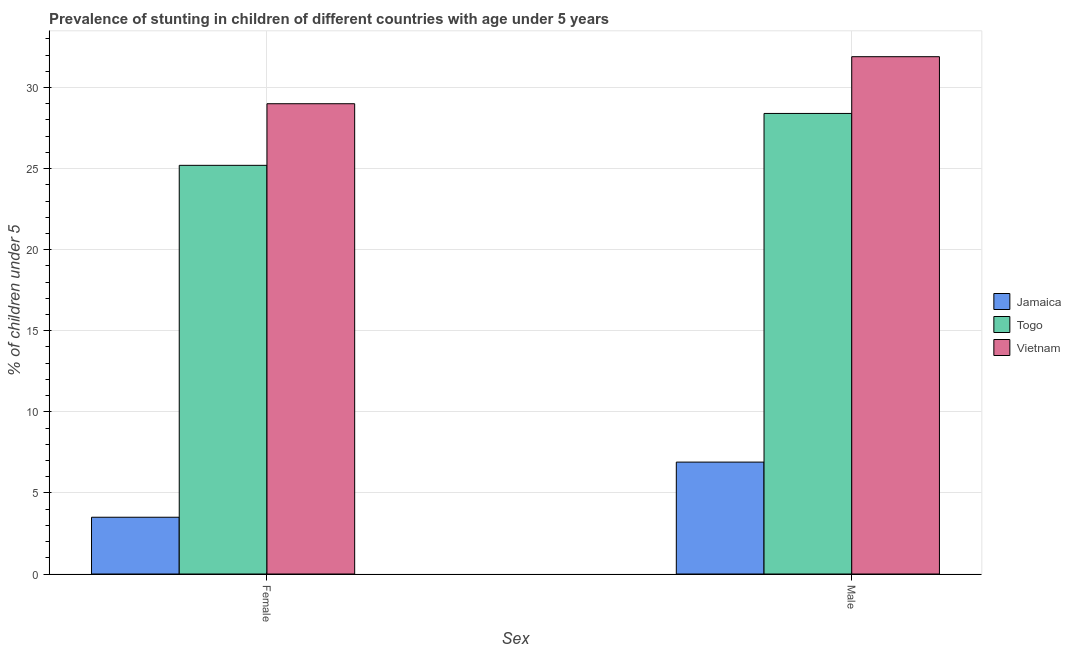Are the number of bars per tick equal to the number of legend labels?
Provide a short and direct response. Yes. How many bars are there on the 1st tick from the left?
Offer a very short reply. 3. How many bars are there on the 2nd tick from the right?
Your answer should be very brief. 3. What is the label of the 1st group of bars from the left?
Your response must be concise. Female. What is the percentage of stunted female children in Togo?
Your answer should be very brief. 25.2. Across all countries, what is the maximum percentage of stunted male children?
Make the answer very short. 31.9. Across all countries, what is the minimum percentage of stunted female children?
Your answer should be very brief. 3.5. In which country was the percentage of stunted male children maximum?
Provide a short and direct response. Vietnam. In which country was the percentage of stunted female children minimum?
Your answer should be compact. Jamaica. What is the total percentage of stunted female children in the graph?
Provide a succinct answer. 57.7. What is the difference between the percentage of stunted male children in Jamaica and that in Vietnam?
Offer a terse response. -25. What is the difference between the percentage of stunted female children in Vietnam and the percentage of stunted male children in Jamaica?
Your answer should be very brief. 22.1. What is the average percentage of stunted male children per country?
Your response must be concise. 22.4. What is the difference between the percentage of stunted female children and percentage of stunted male children in Vietnam?
Keep it short and to the point. -2.9. In how many countries, is the percentage of stunted female children greater than 8 %?
Provide a short and direct response. 2. What is the ratio of the percentage of stunted male children in Vietnam to that in Togo?
Ensure brevity in your answer.  1.12. What does the 3rd bar from the left in Male represents?
Make the answer very short. Vietnam. What does the 2nd bar from the right in Female represents?
Offer a terse response. Togo. Are all the bars in the graph horizontal?
Offer a terse response. No. Where does the legend appear in the graph?
Your answer should be very brief. Center right. What is the title of the graph?
Give a very brief answer. Prevalence of stunting in children of different countries with age under 5 years. Does "Tuvalu" appear as one of the legend labels in the graph?
Your answer should be very brief. No. What is the label or title of the X-axis?
Give a very brief answer. Sex. What is the label or title of the Y-axis?
Make the answer very short.  % of children under 5. What is the  % of children under 5 in Jamaica in Female?
Ensure brevity in your answer.  3.5. What is the  % of children under 5 in Togo in Female?
Your answer should be very brief. 25.2. What is the  % of children under 5 of Vietnam in Female?
Keep it short and to the point. 29. What is the  % of children under 5 of Jamaica in Male?
Provide a succinct answer. 6.9. What is the  % of children under 5 in Togo in Male?
Provide a short and direct response. 28.4. What is the  % of children under 5 of Vietnam in Male?
Your answer should be very brief. 31.9. Across all Sex, what is the maximum  % of children under 5 of Jamaica?
Provide a short and direct response. 6.9. Across all Sex, what is the maximum  % of children under 5 of Togo?
Your answer should be compact. 28.4. Across all Sex, what is the maximum  % of children under 5 in Vietnam?
Offer a terse response. 31.9. Across all Sex, what is the minimum  % of children under 5 of Jamaica?
Ensure brevity in your answer.  3.5. Across all Sex, what is the minimum  % of children under 5 in Togo?
Offer a very short reply. 25.2. Across all Sex, what is the minimum  % of children under 5 in Vietnam?
Your answer should be compact. 29. What is the total  % of children under 5 in Togo in the graph?
Provide a succinct answer. 53.6. What is the total  % of children under 5 in Vietnam in the graph?
Provide a succinct answer. 60.9. What is the difference between the  % of children under 5 in Jamaica in Female and that in Male?
Your answer should be compact. -3.4. What is the difference between the  % of children under 5 in Togo in Female and that in Male?
Keep it short and to the point. -3.2. What is the difference between the  % of children under 5 in Jamaica in Female and the  % of children under 5 in Togo in Male?
Offer a terse response. -24.9. What is the difference between the  % of children under 5 in Jamaica in Female and the  % of children under 5 in Vietnam in Male?
Keep it short and to the point. -28.4. What is the average  % of children under 5 in Togo per Sex?
Provide a short and direct response. 26.8. What is the average  % of children under 5 in Vietnam per Sex?
Keep it short and to the point. 30.45. What is the difference between the  % of children under 5 of Jamaica and  % of children under 5 of Togo in Female?
Provide a short and direct response. -21.7. What is the difference between the  % of children under 5 in Jamaica and  % of children under 5 in Vietnam in Female?
Offer a terse response. -25.5. What is the difference between the  % of children under 5 of Togo and  % of children under 5 of Vietnam in Female?
Offer a terse response. -3.8. What is the difference between the  % of children under 5 in Jamaica and  % of children under 5 in Togo in Male?
Provide a succinct answer. -21.5. What is the ratio of the  % of children under 5 of Jamaica in Female to that in Male?
Your response must be concise. 0.51. What is the ratio of the  % of children under 5 of Togo in Female to that in Male?
Offer a terse response. 0.89. What is the difference between the highest and the second highest  % of children under 5 in Togo?
Provide a short and direct response. 3.2. 